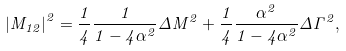<formula> <loc_0><loc_0><loc_500><loc_500>\left | M _ { 1 2 } \right | ^ { 2 } = \frac { 1 } { 4 } \frac { 1 } { 1 - 4 \alpha ^ { 2 } } \Delta M ^ { 2 } + \frac { 1 } { 4 } \frac { \alpha ^ { 2 } } { 1 - 4 \alpha ^ { 2 } } \Delta \Gamma ^ { 2 } ,</formula> 